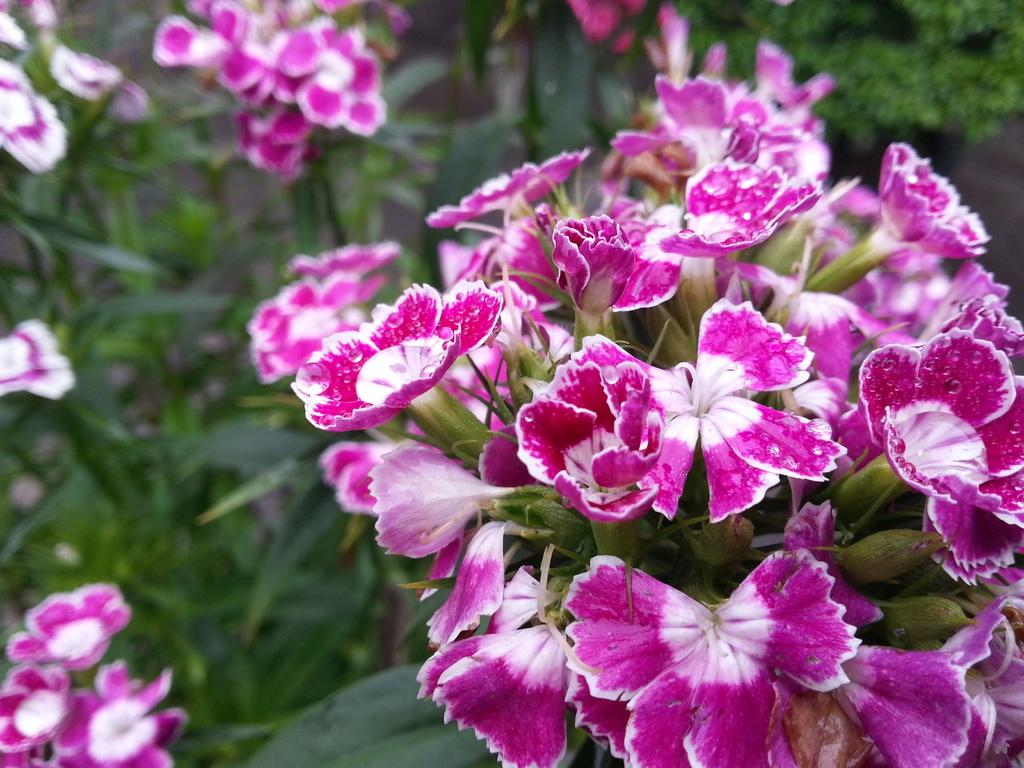What type of living organisms are present in the image? There are plants in the image. What specific features can be observed on the plants? The plants have flowers, and there are buds and leaves visible. What colors are the flowers? The flowers are in violet and white colors. What color are the buds? The buds are green. What color are the leaves? The leaves in the image are green. What type of meat can be seen hanging from the plants in the image? There is no meat present in the image; it features plants with flowers, buds, and leaves. Can you describe the car that is smashing the flowers in the image? There is no car present in the image, nor is there any indication of the flowers being smashed. 